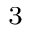<formula> <loc_0><loc_0><loc_500><loc_500>^ { 3 }</formula> 